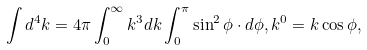<formula> <loc_0><loc_0><loc_500><loc_500>\int d ^ { 4 } k = 4 \pi \int _ { 0 } ^ { \infty } k ^ { 3 } d k \int _ { 0 } ^ { \pi } \sin ^ { 2 } \phi \cdot d \phi , k ^ { 0 } = k \cos \phi ,</formula> 